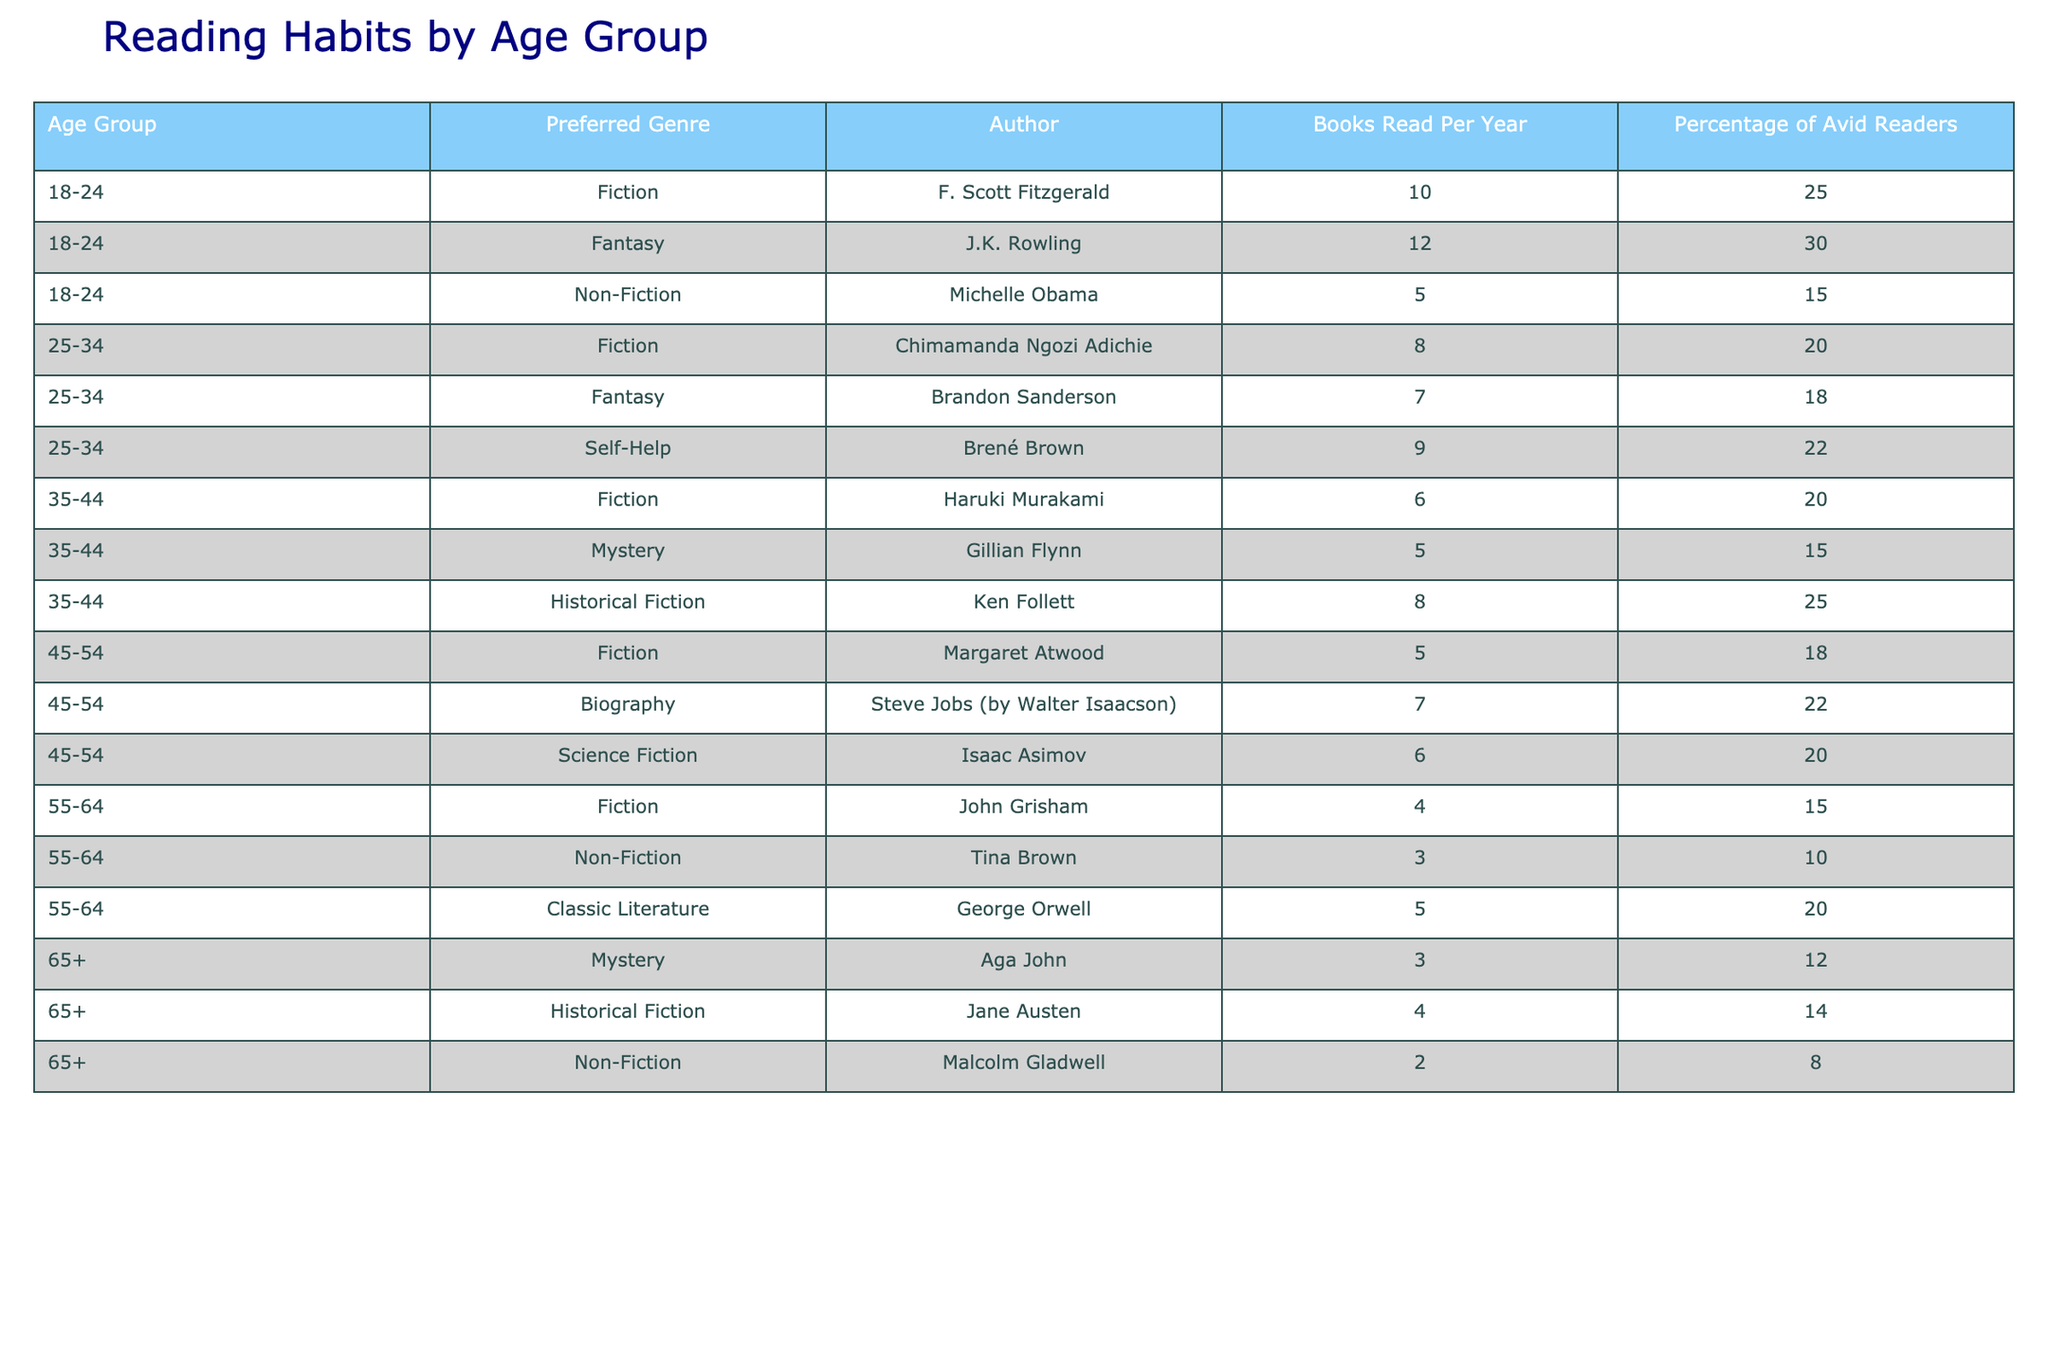What is the preferred genre among the 18-24 age group? The preferred genre for the 18-24 age group is Fantasy, as it has the highest percentage of avid readers (30%) compared to others in that age group.
Answer: Fantasy How many books do 45-54-year-olds read per year on average? The books read per year for the 45-54 age group are 5, 7, and 6. To find the average, we sum these values (5 + 7 + 6 = 18) and divide by the count of genres (3), giving us an average of 18 / 3 = 6.
Answer: 6 Which author has the highest percentage of avid readers in the 25-34 age group? In the 25-34 age group, the authors and their percentages are: Chimamanda Ngozi Adichie (20%), Brandon Sanderson (18%), and Brené Brown (22%). Brené Brown has the highest percentage with 22%.
Answer: Brené Brown Is fiction the most preferred genre for any age group? Yes, Fiction is the most preferred genre for the age groups 18-24, 25-34, 35-44, and 45-54 as it has the highest percentage of avid readers among the listed genres in those groups.
Answer: Yes What is the total percentage of avid readers interested in Non-Fiction across all age groups? The percentages of avid readers for Non-Fiction are 15% (18-24), 0% (25-34), 0% (35-44), 22% (45-54), 10% (55-64), and 8% (65+), summing these gives us 15 + 0 + 0 + 22 + 10 + 8 = 55%.
Answer: 55% Which age group has the lowest average number of books read per year? To find the average books read per year for each age group: 18-24 (10 + 12 + 5) / 3 = 9, 25-34 (8 + 7 + 9) / 3 = 8, 35-44 (6 + 5 + 8) / 3 = 6.33, 45-54 (5 + 7 + 6) / 3 = 6, 55-64 (4 + 3 + 5) / 3 = 4, and 65+ (3 + 4 + 2) / 3 = 3. Therefore, the 65+ age group has the lowest average.
Answer: 65+ What genre do 55-64-year-olds prefer the least? Among the genres for the 55-64 age group, Non-Fiction has the lowest percentage of avid readers at 10%.
Answer: Non-Fiction How does the percentage of avid readers in Historical Fiction compare between the 35-44 and 65+ age groups? For the 35-44 age group, the percentage for Historical Fiction is 25%, while for the 65+ age group it is 14%. Therefore, 35-44 has a higher percentage than 65+.
Answer: Higher in 35-44 